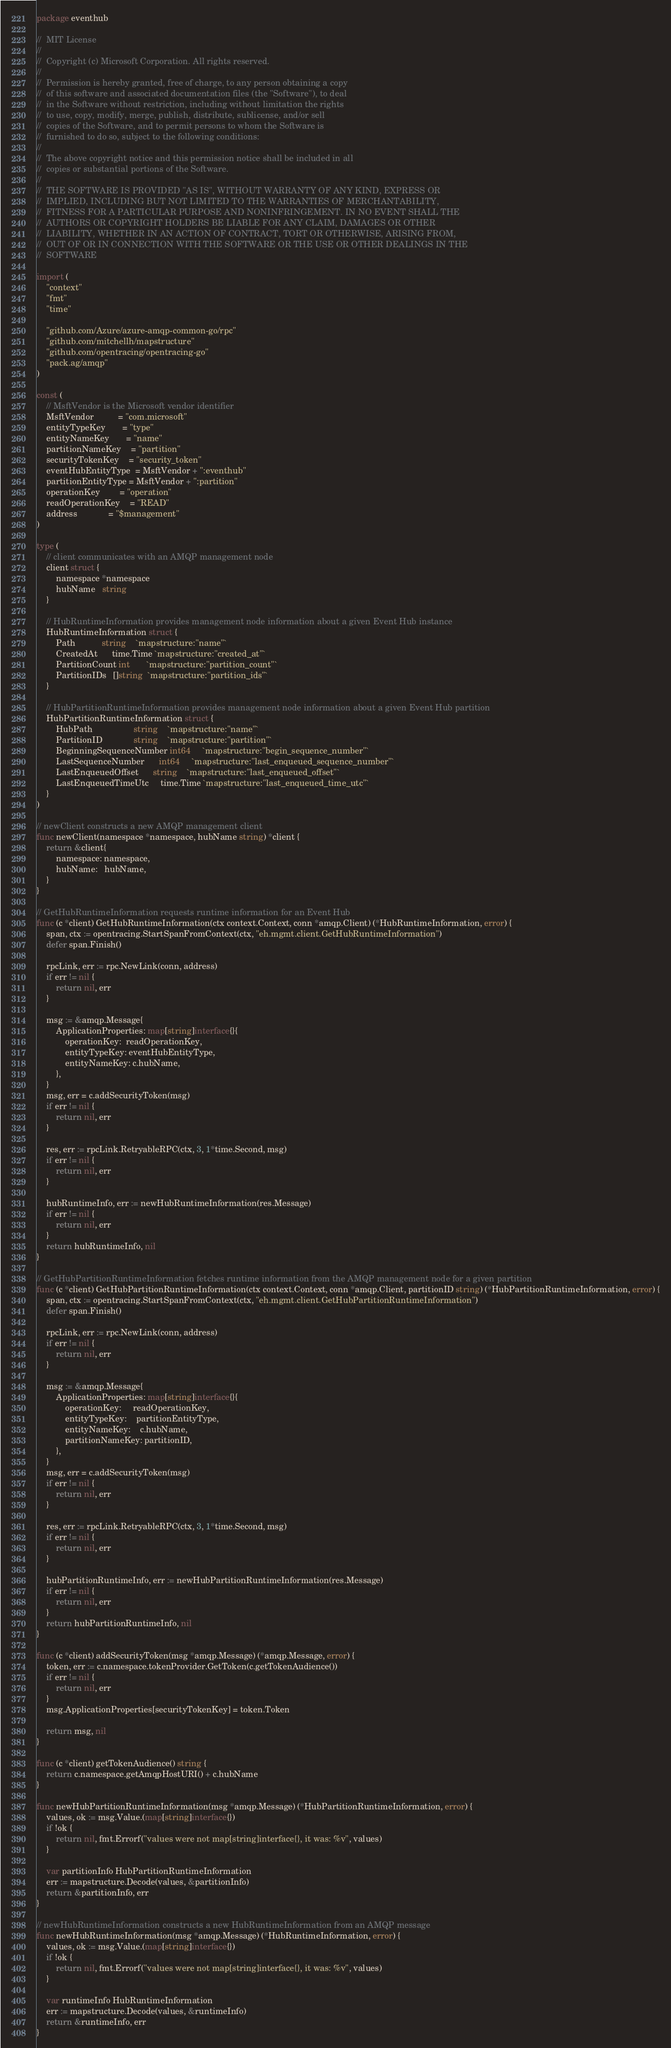Convert code to text. <code><loc_0><loc_0><loc_500><loc_500><_Go_>package eventhub

//	MIT License
//
//	Copyright (c) Microsoft Corporation. All rights reserved.
//
//	Permission is hereby granted, free of charge, to any person obtaining a copy
//	of this software and associated documentation files (the "Software"), to deal
//	in the Software without restriction, including without limitation the rights
//	to use, copy, modify, merge, publish, distribute, sublicense, and/or sell
//	copies of the Software, and to permit persons to whom the Software is
//	furnished to do so, subject to the following conditions:
//
//	The above copyright notice and this permission notice shall be included in all
//	copies or substantial portions of the Software.
//
//	THE SOFTWARE IS PROVIDED "AS IS", WITHOUT WARRANTY OF ANY KIND, EXPRESS OR
//	IMPLIED, INCLUDING BUT NOT LIMITED TO THE WARRANTIES OF MERCHANTABILITY,
//	FITNESS FOR A PARTICULAR PURPOSE AND NONINFRINGEMENT. IN NO EVENT SHALL THE
//	AUTHORS OR COPYRIGHT HOLDERS BE LIABLE FOR ANY CLAIM, DAMAGES OR OTHER
//	LIABILITY, WHETHER IN AN ACTION OF CONTRACT, TORT OR OTHERWISE, ARISING FROM,
//	OUT OF OR IN CONNECTION WITH THE SOFTWARE OR THE USE OR OTHER DEALINGS IN THE
//	SOFTWARE

import (
	"context"
	"fmt"
	"time"

	"github.com/Azure/azure-amqp-common-go/rpc"
	"github.com/mitchellh/mapstructure"
	"github.com/opentracing/opentracing-go"
	"pack.ag/amqp"
)

const (
	// MsftVendor is the Microsoft vendor identifier
	MsftVendor          = "com.microsoft"
	entityTypeKey       = "type"
	entityNameKey       = "name"
	partitionNameKey    = "partition"
	securityTokenKey    = "security_token"
	eventHubEntityType  = MsftVendor + ":eventhub"
	partitionEntityType = MsftVendor + ":partition"
	operationKey        = "operation"
	readOperationKey    = "READ"
	address             = "$management"
)

type (
	// client communicates with an AMQP management node
	client struct {
		namespace *namespace
		hubName   string
	}

	// HubRuntimeInformation provides management node information about a given Event Hub instance
	HubRuntimeInformation struct {
		Path           string    `mapstructure:"name"`
		CreatedAt      time.Time `mapstructure:"created_at"`
		PartitionCount int       `mapstructure:"partition_count"`
		PartitionIDs   []string  `mapstructure:"partition_ids"`
	}

	// HubPartitionRuntimeInformation provides management node information about a given Event Hub partition
	HubPartitionRuntimeInformation struct {
		HubPath                 string    `mapstructure:"name"`
		PartitionID             string    `mapstructure:"partition"`
		BeginningSequenceNumber int64     `mapstructure:"begin_sequence_number"`
		LastSequenceNumber      int64     `mapstructure:"last_enqueued_sequence_number"`
		LastEnqueuedOffset      string    `mapstructure:"last_enqueued_offset"`
		LastEnqueuedTimeUtc     time.Time `mapstructure:"last_enqueued_time_utc"`
	}
)

// newClient constructs a new AMQP management client
func newClient(namespace *namespace, hubName string) *client {
	return &client{
		namespace: namespace,
		hubName:   hubName,
	}
}

// GetHubRuntimeInformation requests runtime information for an Event Hub
func (c *client) GetHubRuntimeInformation(ctx context.Context, conn *amqp.Client) (*HubRuntimeInformation, error) {
	span, ctx := opentracing.StartSpanFromContext(ctx, "eh.mgmt.client.GetHubRuntimeInformation")
	defer span.Finish()

	rpcLink, err := rpc.NewLink(conn, address)
	if err != nil {
		return nil, err
	}

	msg := &amqp.Message{
		ApplicationProperties: map[string]interface{}{
			operationKey:  readOperationKey,
			entityTypeKey: eventHubEntityType,
			entityNameKey: c.hubName,
		},
	}
	msg, err = c.addSecurityToken(msg)
	if err != nil {
		return nil, err
	}

	res, err := rpcLink.RetryableRPC(ctx, 3, 1*time.Second, msg)
	if err != nil {
		return nil, err
	}

	hubRuntimeInfo, err := newHubRuntimeInformation(res.Message)
	if err != nil {
		return nil, err
	}
	return hubRuntimeInfo, nil
}

// GetHubPartitionRuntimeInformation fetches runtime information from the AMQP management node for a given partition
func (c *client) GetHubPartitionRuntimeInformation(ctx context.Context, conn *amqp.Client, partitionID string) (*HubPartitionRuntimeInformation, error) {
	span, ctx := opentracing.StartSpanFromContext(ctx, "eh.mgmt.client.GetHubPartitionRuntimeInformation")
	defer span.Finish()

	rpcLink, err := rpc.NewLink(conn, address)
	if err != nil {
		return nil, err
	}

	msg := &amqp.Message{
		ApplicationProperties: map[string]interface{}{
			operationKey:     readOperationKey,
			entityTypeKey:    partitionEntityType,
			entityNameKey:    c.hubName,
			partitionNameKey: partitionID,
		},
	}
	msg, err = c.addSecurityToken(msg)
	if err != nil {
		return nil, err
	}

	res, err := rpcLink.RetryableRPC(ctx, 3, 1*time.Second, msg)
	if err != nil {
		return nil, err
	}

	hubPartitionRuntimeInfo, err := newHubPartitionRuntimeInformation(res.Message)
	if err != nil {
		return nil, err
	}
	return hubPartitionRuntimeInfo, nil
}

func (c *client) addSecurityToken(msg *amqp.Message) (*amqp.Message, error) {
	token, err := c.namespace.tokenProvider.GetToken(c.getTokenAudience())
	if err != nil {
		return nil, err
	}
	msg.ApplicationProperties[securityTokenKey] = token.Token

	return msg, nil
}

func (c *client) getTokenAudience() string {
	return c.namespace.getAmqpHostURI() + c.hubName
}

func newHubPartitionRuntimeInformation(msg *amqp.Message) (*HubPartitionRuntimeInformation, error) {
	values, ok := msg.Value.(map[string]interface{})
	if !ok {
		return nil, fmt.Errorf("values were not map[string]interface{}, it was: %v", values)
	}

	var partitionInfo HubPartitionRuntimeInformation
	err := mapstructure.Decode(values, &partitionInfo)
	return &partitionInfo, err
}

// newHubRuntimeInformation constructs a new HubRuntimeInformation from an AMQP message
func newHubRuntimeInformation(msg *amqp.Message) (*HubRuntimeInformation, error) {
	values, ok := msg.Value.(map[string]interface{})
	if !ok {
		return nil, fmt.Errorf("values were not map[string]interface{}, it was: %v", values)
	}

	var runtimeInfo HubRuntimeInformation
	err := mapstructure.Decode(values, &runtimeInfo)
	return &runtimeInfo, err
}
</code> 